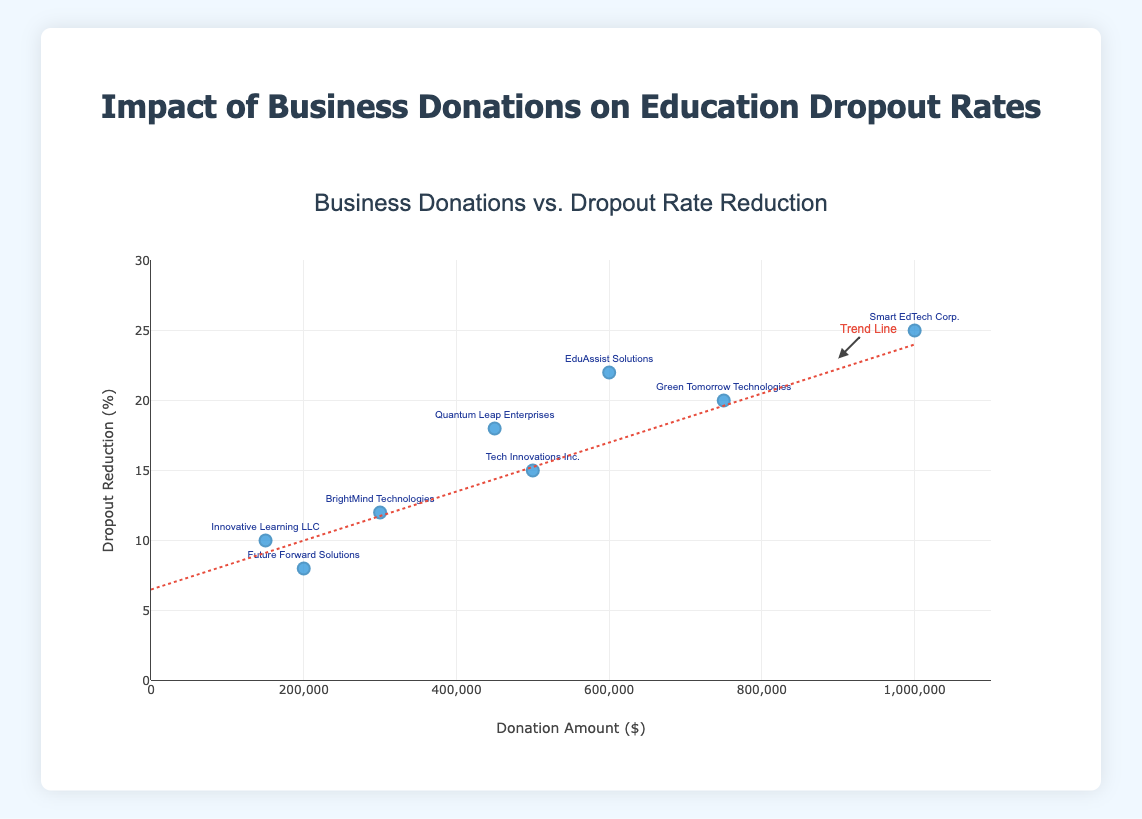What is the title of the plot? The title is found at the top of the plot in large, prominent text, indicating the main subject of the figure.
Answer: Impact of Business Donations on Education Dropout Rates How many data points are shown in the scatter plot? Each data point represents a business entity's donation amount and its corresponding dropout rate reduction. By counting the points on the plot, we see there are 8.
Answer: 8 Which business entity contributed the most in donations? Each point is labeled with a business entity's name. The point furthest to the right on the x-axis represents the highest donation.
Answer: Smart EdTech Corp Which business entity achieved the highest dropout reduction percentage? Look for the point highest up on the y-axis to find the business that achieved the highest dropout reduction.
Answer: Smart EdTech Corp How much is the donation amount for Quantum Leap Enterprises? Locate the data point labeled "Quantum Leap Enterprises" and note the x-value, which represents the donation amount.
Answer: $450,000 Compare the dropout reduction percentage between BrightMind Technologies and Innovative Learning LLC. Find the points labeled with these business names and compare their y-values, which indicate the dropout reduction percentage.
Answer: BrightMind Technologies: 12%, Innovative Learning LLC: 10% What is the trend line indicating in the plot? The trend line is a dashed line running through the plot, indicating the overall relationship between donation amounts and dropout reduction percentages. Based on its upward slope, it shows that higher donations are generally associated with greater dropout reductions.
Answer: Higher donations generally lead to greater dropout reductions Which business entity made a donation of $750,000 and what is the corresponding dropout reduction percentage? Locate the data point on the x-axis at $750,000 and read the label, then check the y-value for the dropout reduction percentage.
Answer: Green Tomorrow Technologies, 20% Compare the dropout reduction percentages of businesses that donated $500,000 and $600,000. Identify the points at $500,000 and $600,000 on the x-axis and compare their corresponding y-values.
Answer: 15% and 22% How does the average dropout reduction percentage for donations greater than $400,000 compare to those less than $400,000? Identify the data points with donations greater and less than $400,000, calculate the average dropout reduction for each group, and compare the two averages. Donations greater than $400,000: (15 + 20 + 25 + 18 + 22)/5 = 20%, Donations less than $400,000: (8 + 10 + 12)/3 ≈ 10%
Answer: Greater donations average 20%, less donations average ≈10% 